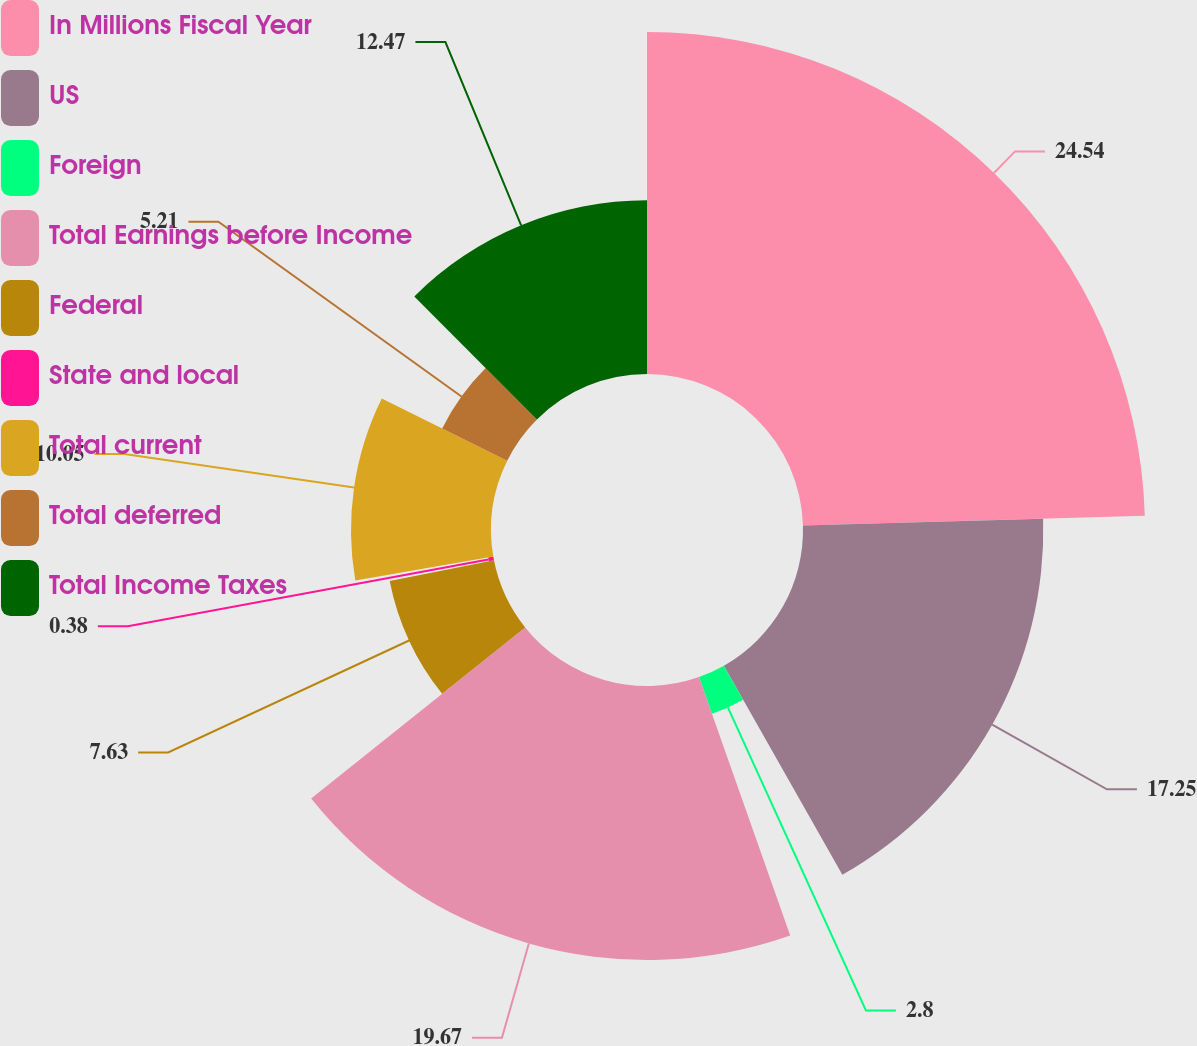Convert chart. <chart><loc_0><loc_0><loc_500><loc_500><pie_chart><fcel>In Millions Fiscal Year<fcel>US<fcel>Foreign<fcel>Total Earnings before Income<fcel>Federal<fcel>State and local<fcel>Total current<fcel>Total deferred<fcel>Total Income Taxes<nl><fcel>24.55%<fcel>17.25%<fcel>2.8%<fcel>19.67%<fcel>7.63%<fcel>0.38%<fcel>10.05%<fcel>5.21%<fcel>12.47%<nl></chart> 